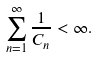<formula> <loc_0><loc_0><loc_500><loc_500>\sum _ { n = 1 } ^ { \infty } { \frac { 1 } { C _ { n } } } < \infty .</formula> 